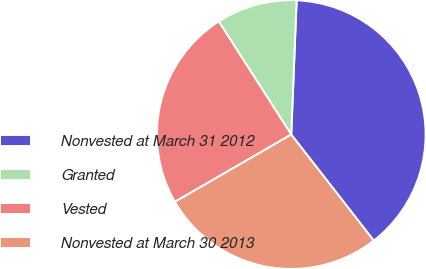<chart> <loc_0><loc_0><loc_500><loc_500><pie_chart><fcel>Nonvested at March 31 2012<fcel>Granted<fcel>Vested<fcel>Nonvested at March 30 2013<nl><fcel>38.83%<fcel>9.71%<fcel>24.27%<fcel>27.18%<nl></chart> 